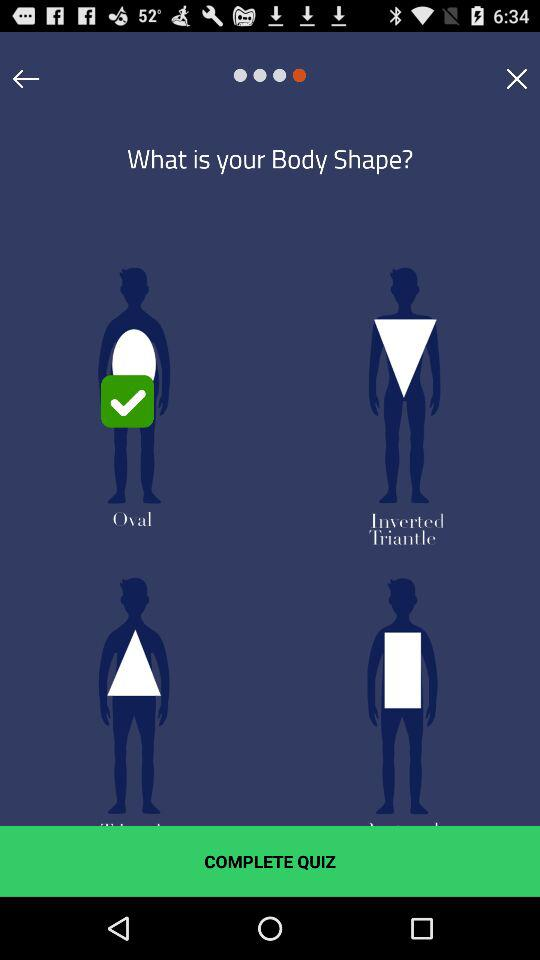How many body shapes are there?
Answer the question using a single word or phrase. 4 